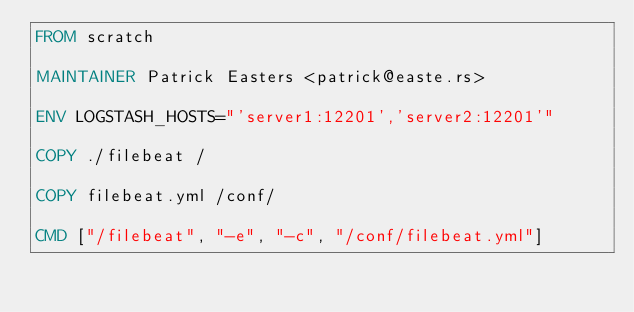Convert code to text. <code><loc_0><loc_0><loc_500><loc_500><_Dockerfile_>FROM scratch

MAINTAINER Patrick Easters <patrick@easte.rs>

ENV LOGSTASH_HOSTS="'server1:12201','server2:12201'"

COPY ./filebeat /

COPY filebeat.yml /conf/

CMD ["/filebeat", "-e", "-c", "/conf/filebeat.yml"]
</code> 